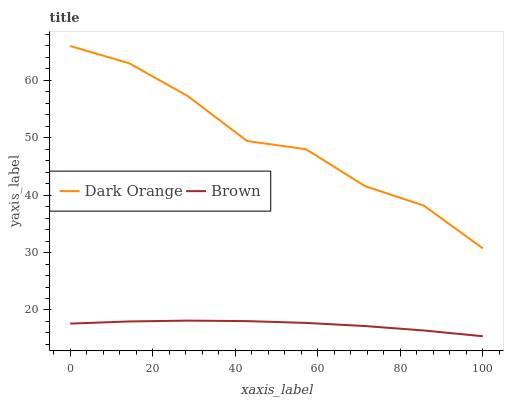Does Brown have the minimum area under the curve?
Answer yes or no. Yes. Does Dark Orange have the maximum area under the curve?
Answer yes or no. Yes. Does Brown have the maximum area under the curve?
Answer yes or no. No. Is Brown the smoothest?
Answer yes or no. Yes. Is Dark Orange the roughest?
Answer yes or no. Yes. Is Brown the roughest?
Answer yes or no. No. Does Brown have the highest value?
Answer yes or no. No. Is Brown less than Dark Orange?
Answer yes or no. Yes. Is Dark Orange greater than Brown?
Answer yes or no. Yes. Does Brown intersect Dark Orange?
Answer yes or no. No. 